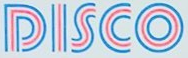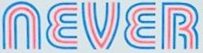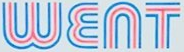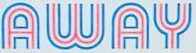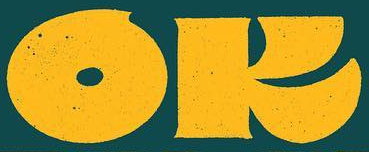Transcribe the words shown in these images in order, separated by a semicolon. DISCO; NEVER; WENT; AWAY; OK 